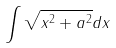<formula> <loc_0><loc_0><loc_500><loc_500>\int \sqrt { x ^ { 2 } + a ^ { 2 } } d x</formula> 